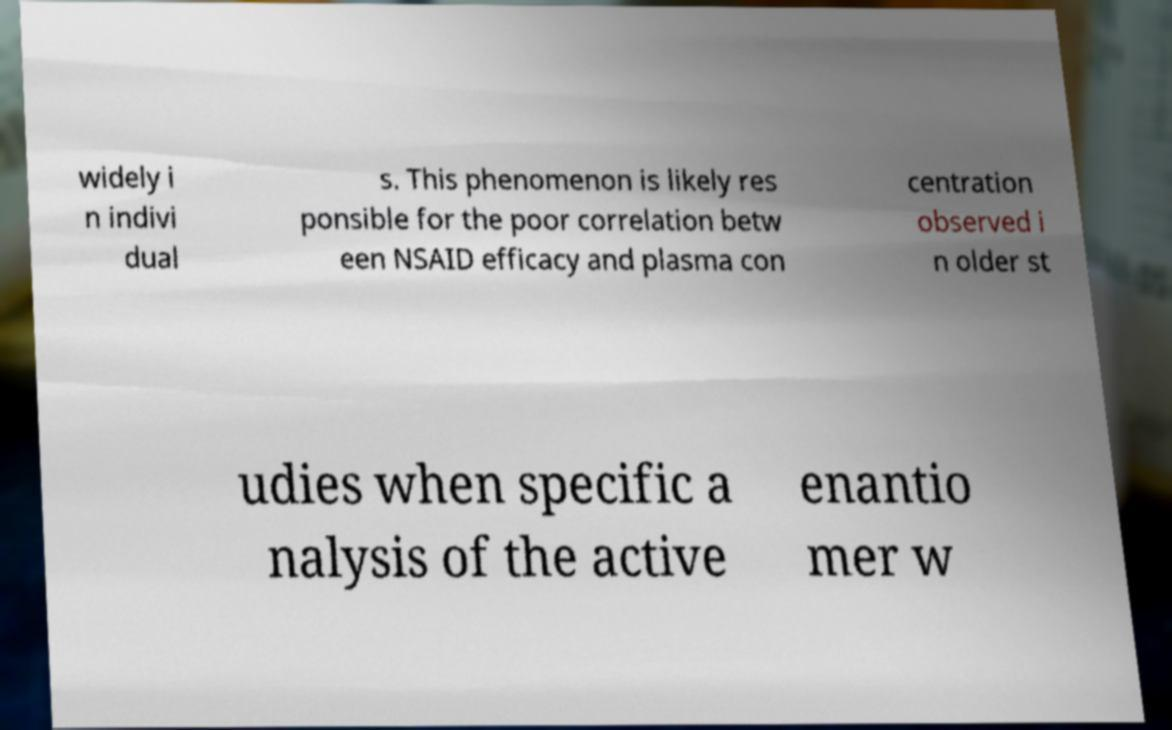Could you extract and type out the text from this image? widely i n indivi dual s. This phenomenon is likely res ponsible for the poor correlation betw een NSAID efficacy and plasma con centration observed i n older st udies when specific a nalysis of the active enantio mer w 